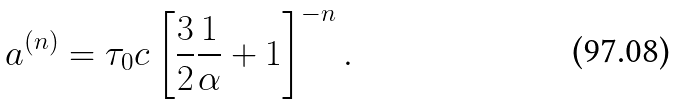<formula> <loc_0><loc_0><loc_500><loc_500>a ^ { ( n ) } = \tau _ { 0 } c \left [ { \frac { 3 } { 2 } \frac { 1 } { \alpha } + 1 } \right ] ^ { - n } .</formula> 